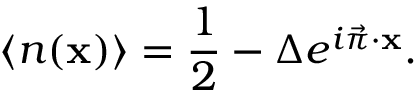<formula> <loc_0><loc_0><loc_500><loc_500>\langle { n } ( { x } ) \rangle = { \frac { 1 } { 2 } } - \Delta e ^ { i \vec { \pi } \cdot { x } } .</formula> 